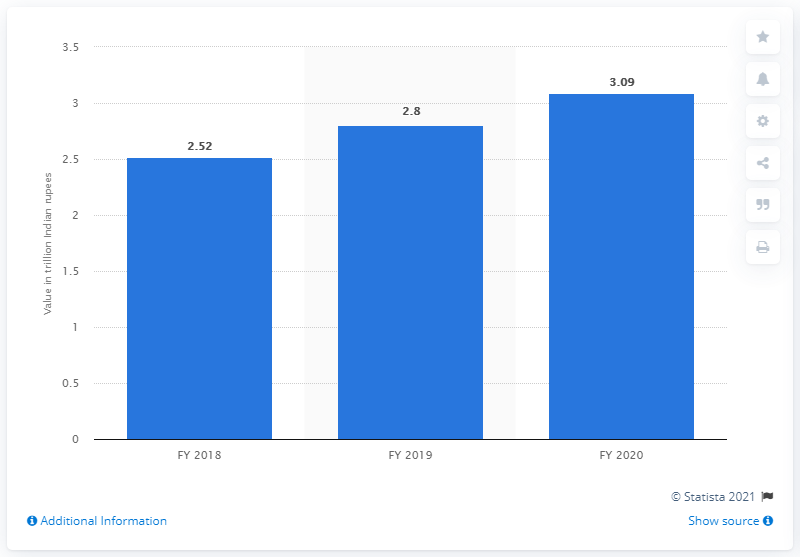Identify some key points in this picture. At the end of the fiscal year 2020, the total assets of Indian Bank were equal to 3.09... 